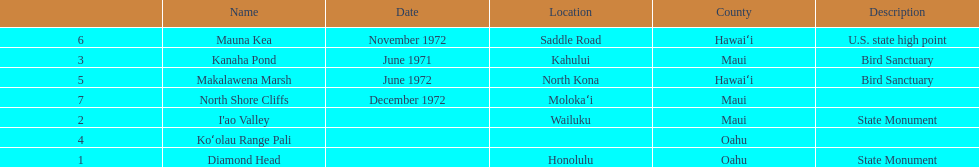Other than mauna kea, name a place in hawaii. Makalawena Marsh. 